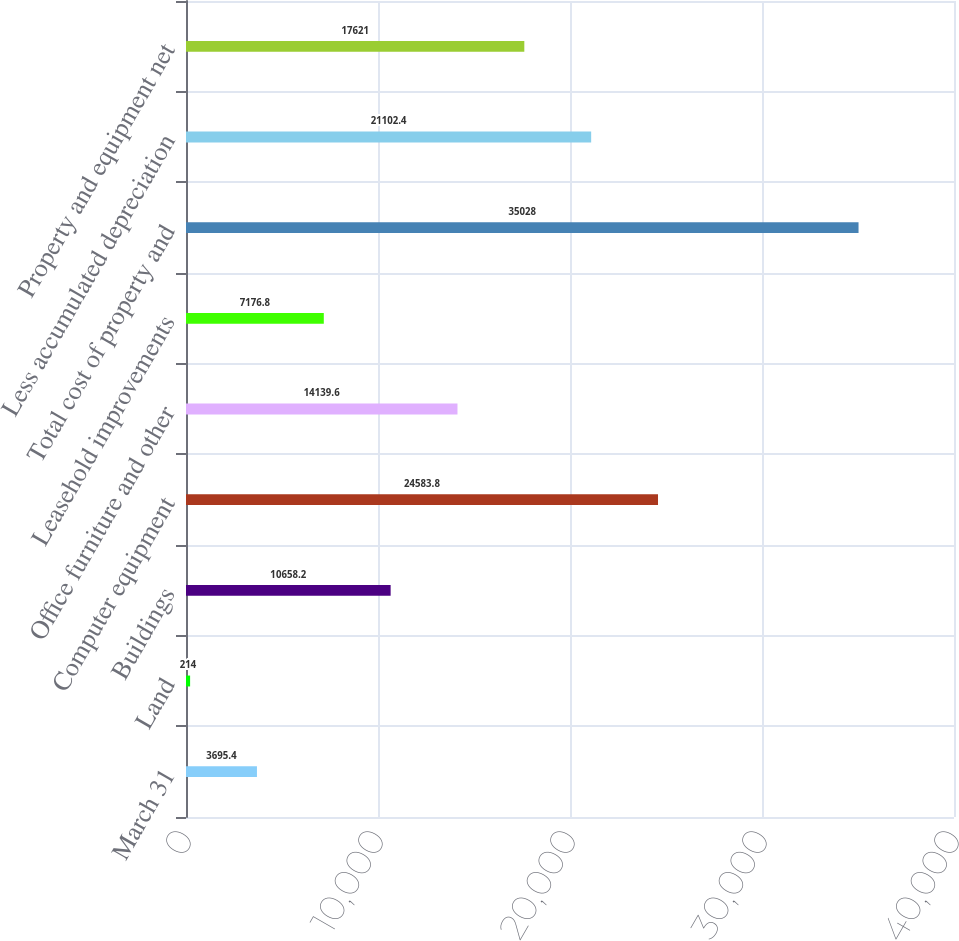Convert chart to OTSL. <chart><loc_0><loc_0><loc_500><loc_500><bar_chart><fcel>March 31<fcel>Land<fcel>Buildings<fcel>Computer equipment<fcel>Office furniture and other<fcel>Leasehold improvements<fcel>Total cost of property and<fcel>Less accumulated depreciation<fcel>Property and equipment net<nl><fcel>3695.4<fcel>214<fcel>10658.2<fcel>24583.8<fcel>14139.6<fcel>7176.8<fcel>35028<fcel>21102.4<fcel>17621<nl></chart> 